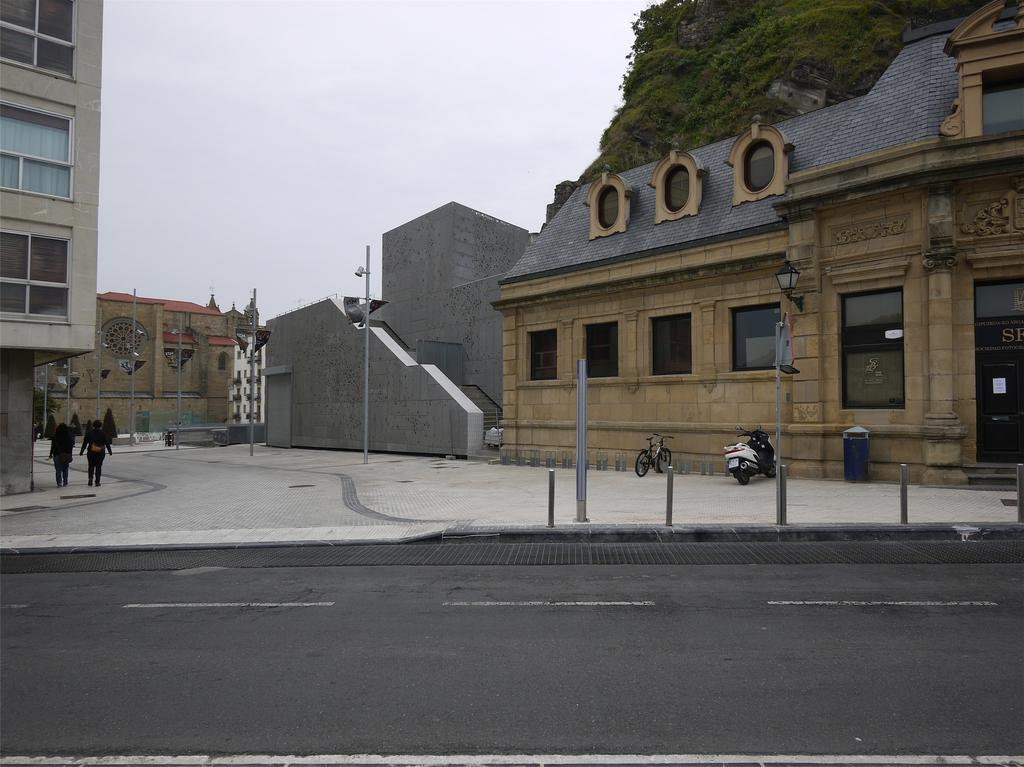What type of structures can be seen in the image? There are buildings in the image. What other objects can be seen in the image? There are poles, a bin, a bicycle, and a bike in the image. What is the setting of the image? There is a road in the image, and there are people present. What can be seen in the background of the image? There is a mountain and sky visible in the background of the image. What type of acoustics can be heard in the image? There is no information about sounds or acoustics in the image, so it cannot be determined. What scent is present in the image? There is no information about scents in the image, so it cannot be determined. 